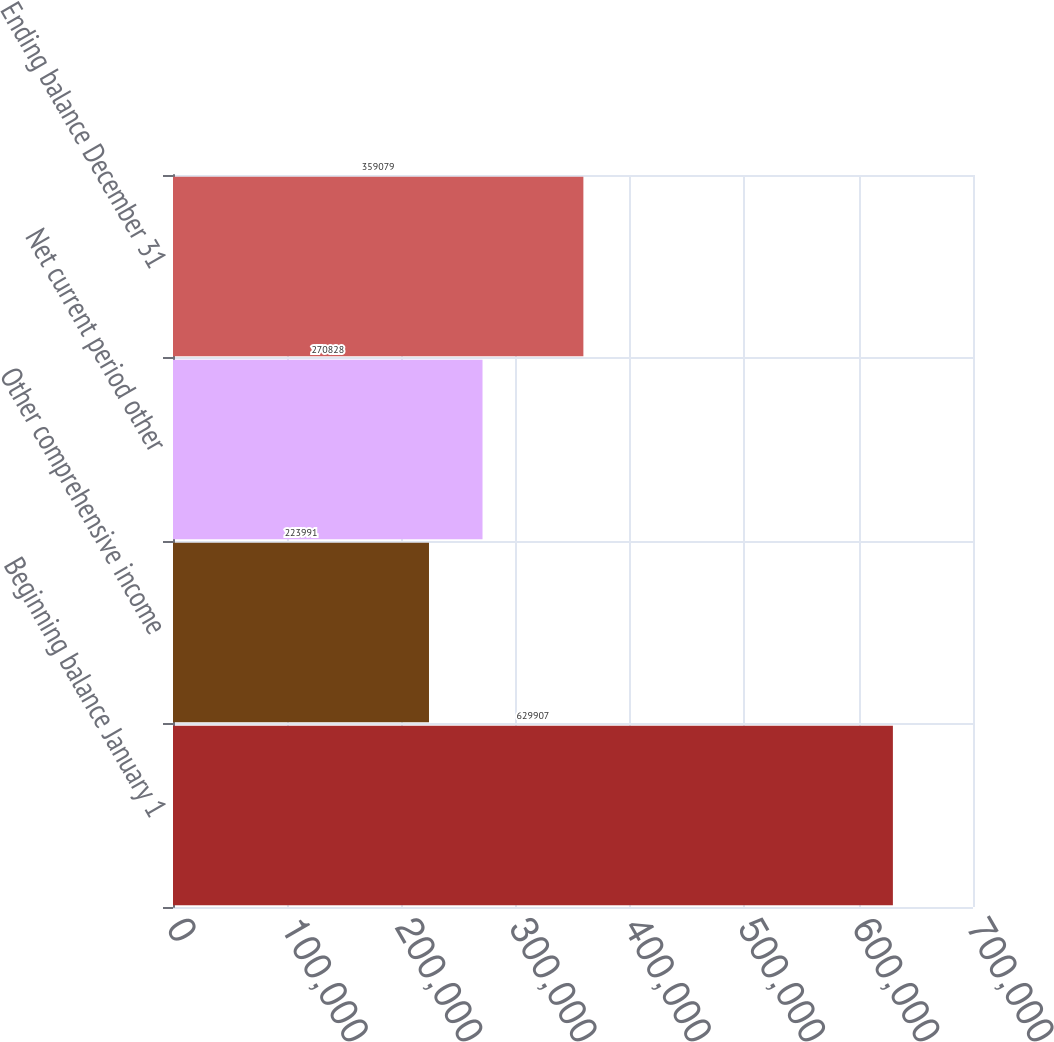Convert chart to OTSL. <chart><loc_0><loc_0><loc_500><loc_500><bar_chart><fcel>Beginning balance January 1<fcel>Other comprehensive income<fcel>Net current period other<fcel>Ending balance December 31<nl><fcel>629907<fcel>223991<fcel>270828<fcel>359079<nl></chart> 